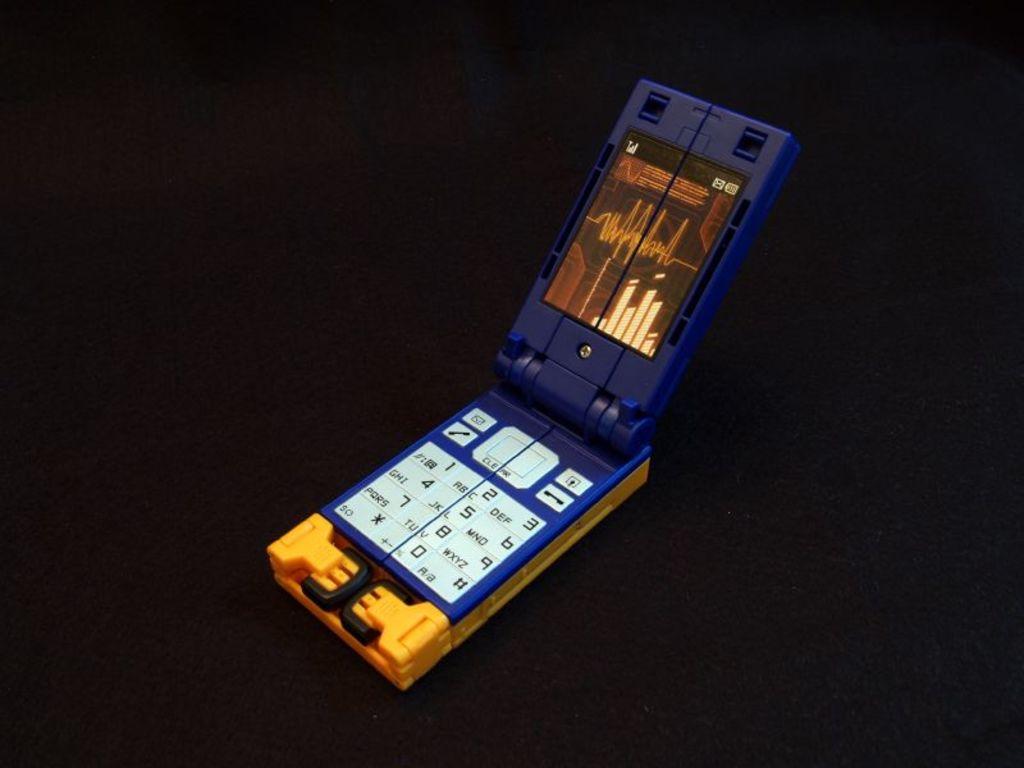What is the first number shown on the keypad?
Provide a succinct answer. 1. 